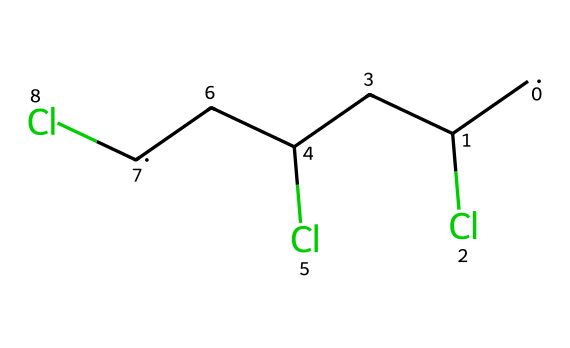What is the full name of this chemical? The provided SMILES representation corresponds to polyvinyl chloride. It indicates the presence of repeating units of vinyl chloride monomer, establishing its identity.
Answer: polyvinyl chloride How many chlorine atoms are present in this molecule? Upon analyzing the SMILES structure, there are three chlorine atoms represented by the "(Cl)" groups. This count determines the substitution in the polymer structure.
Answer: three What type of polymer is represented by this structure? The structure is indicative of an addition polymer, specifically formed through the polymerization of vinyl chloride monomers. This classification is based on the mechanism of formation without the elimination of small molecules.
Answer: addition polymer How does the presence of chlorine affect the properties of this plastic? Chlorine increases the density and rigidity of the polymer, contributes to its flame resistance, and influences its thermal stability, making the resulting plastic more versatile and durable.
Answer: increases density and rigidity What are the primary uses of this plastic? Polyvinyl chloride is prominently used in construction materials, piping, and vinyl records, notably for its durability and resistance to environmental factors, contributing to its widespread application.
Answer: construction materials and vinyl records What is the molecular formula of this compound? The SMILES representation leads to the molecular formula C3H3Cl3, as deduced from counting carbon, hydrogen, and chlorine atoms in the arrangement.
Answer: C3H3Cl3 How many carbon atoms are present in this polymer chain? The structure indicates that there are three carbon atoms, each represented by the [CH2] and [CH] groups. This count is fundamental to defining the backbone of the polymer.
Answer: three 